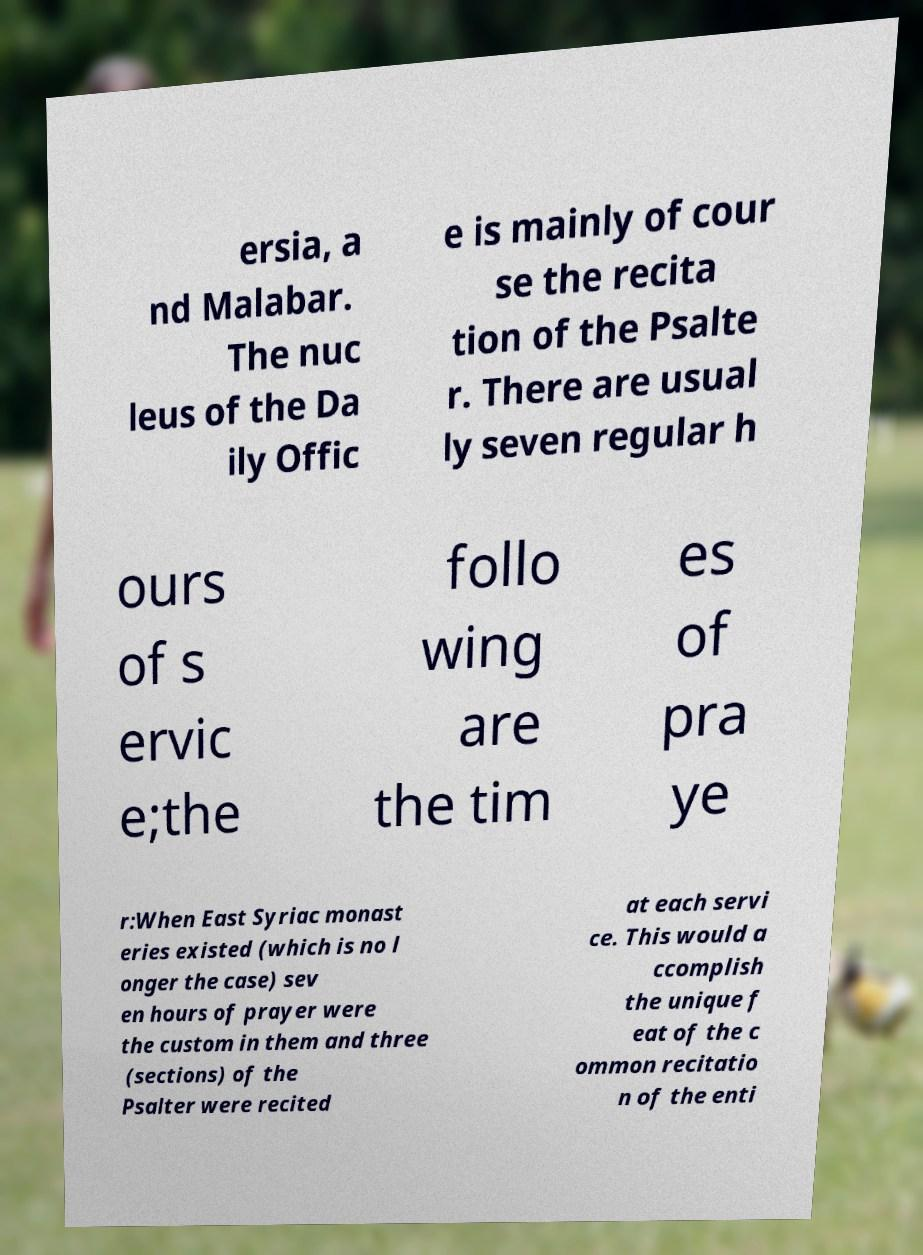There's text embedded in this image that I need extracted. Can you transcribe it verbatim? ersia, a nd Malabar. The nuc leus of the Da ily Offic e is mainly of cour se the recita tion of the Psalte r. There are usual ly seven regular h ours of s ervic e;the follo wing are the tim es of pra ye r:When East Syriac monast eries existed (which is no l onger the case) sev en hours of prayer were the custom in them and three (sections) of the Psalter were recited at each servi ce. This would a ccomplish the unique f eat of the c ommon recitatio n of the enti 